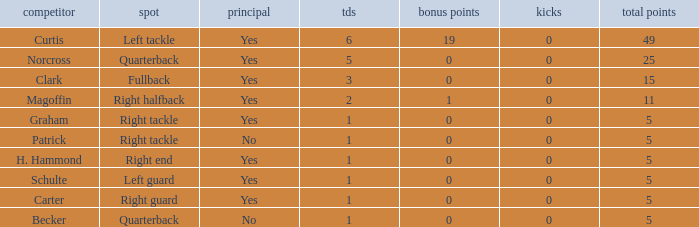Name the number of field goals for 19 extra points 1.0. 